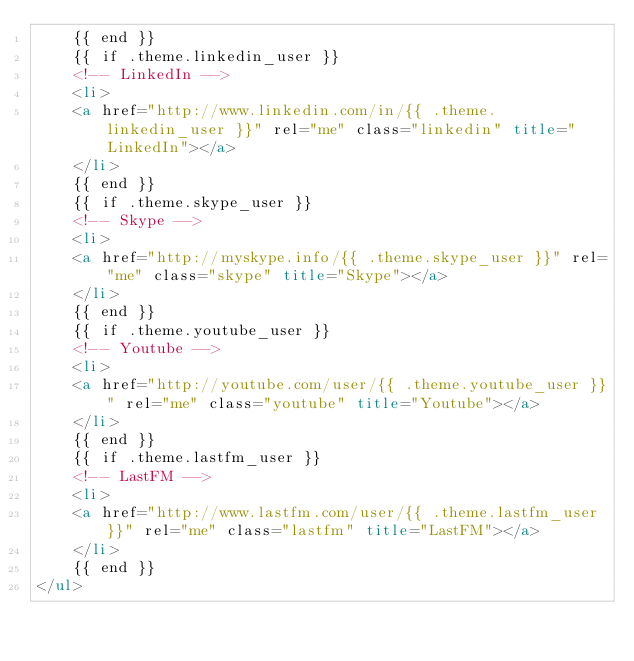Convert code to text. <code><loc_0><loc_0><loc_500><loc_500><_HTML_>    {{ end }}
    {{ if .theme.linkedin_user }}
    <!-- LinkedIn -->
    <li>
    <a href="http://www.linkedin.com/in/{{ .theme.linkedin_user }}" rel="me" class="linkedin" title="LinkedIn"></a>
    </li>
    {{ end }}
    {{ if .theme.skype_user }}
    <!-- Skype -->
    <li>
    <a href="http://myskype.info/{{ .theme.skype_user }}" rel="me" class="skype" title="Skype"></a>
    </li>
    {{ end }}
    {{ if .theme.youtube_user }}
    <!-- Youtube -->
    <li>
    <a href="http://youtube.com/user/{{ .theme.youtube_user }}" rel="me" class="youtube" title="Youtube"></a>
    </li>
    {{ end }}
    {{ if .theme.lastfm_user }}
    <!-- LastFM -->
    <li>
    <a href="http://www.lastfm.com/user/{{ .theme.lastfm_user }}" rel="me" class="lastfm" title="LastFM"></a>
    </li>
    {{ end }}
</ul>
</code> 